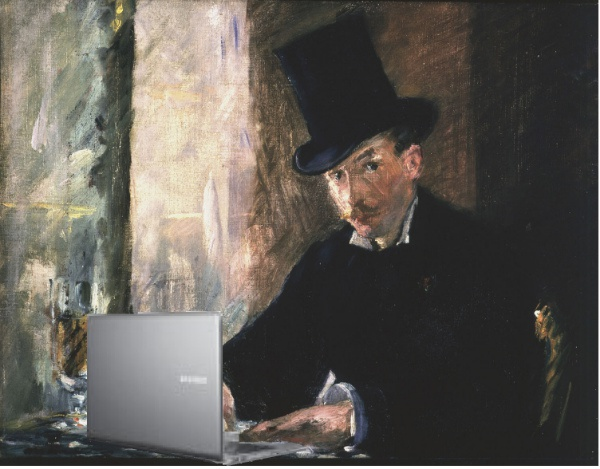Describe the objects in this image and their specific colors. I can see people in gray and black tones, laptop in gray, darkgray, and lightgray tones, and chair in gray and black tones in this image. 